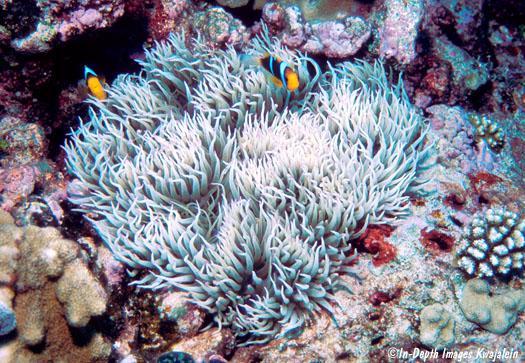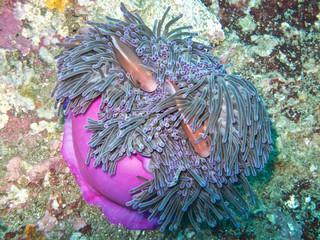The first image is the image on the left, the second image is the image on the right. Given the left and right images, does the statement "In at least one image, there is a single purple round corral underneath green corral arms that fish are swimming through." hold true? Answer yes or no. Yes. The first image is the image on the left, the second image is the image on the right. Considering the images on both sides, is "The right image shows at least two orange fish swimming in tendrils that sprout from an anemone's round purple stalk." valid? Answer yes or no. Yes. 